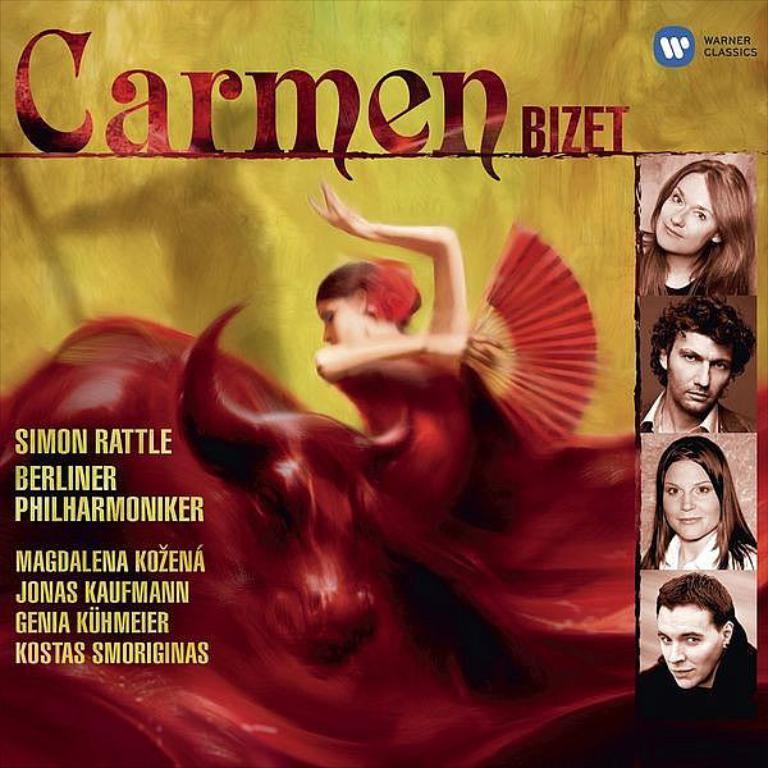How would you summarize this image in a sentence or two? In this image we can see a poster with text. Also there are images of persons. And we can see an edited image of lady holding something in the hand. Also we can see an animal. 